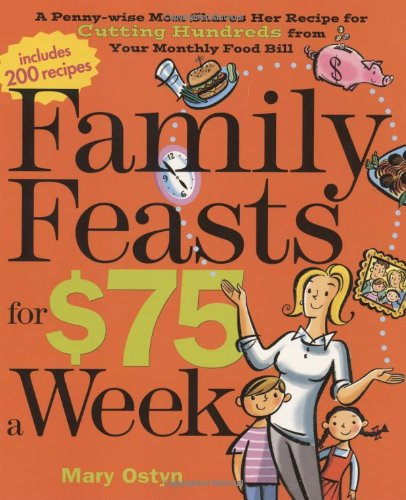Can you provide a sample recipe from this book that families can try? One sample recipe from the book is 'Hearty Lentil Stew'. It uses affordable ingredients like lentils, carrots, and potatoes, and is both filling and nutritious for family dinners. 